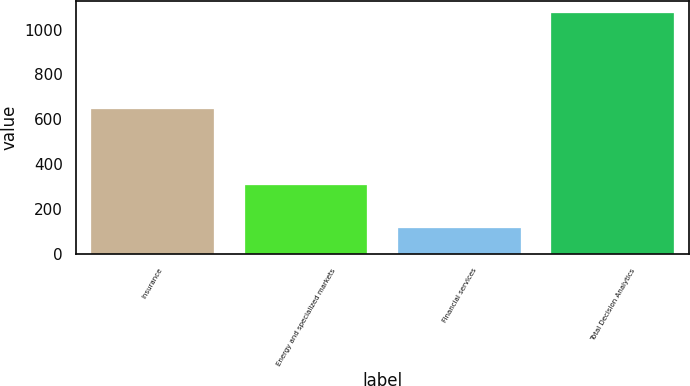Convert chart to OTSL. <chart><loc_0><loc_0><loc_500><loc_500><bar_chart><fcel>Insurance<fcel>Energy and specialized markets<fcel>Financial services<fcel>Total Decision Analytics<nl><fcel>647.2<fcel>308.8<fcel>116.5<fcel>1072.5<nl></chart> 